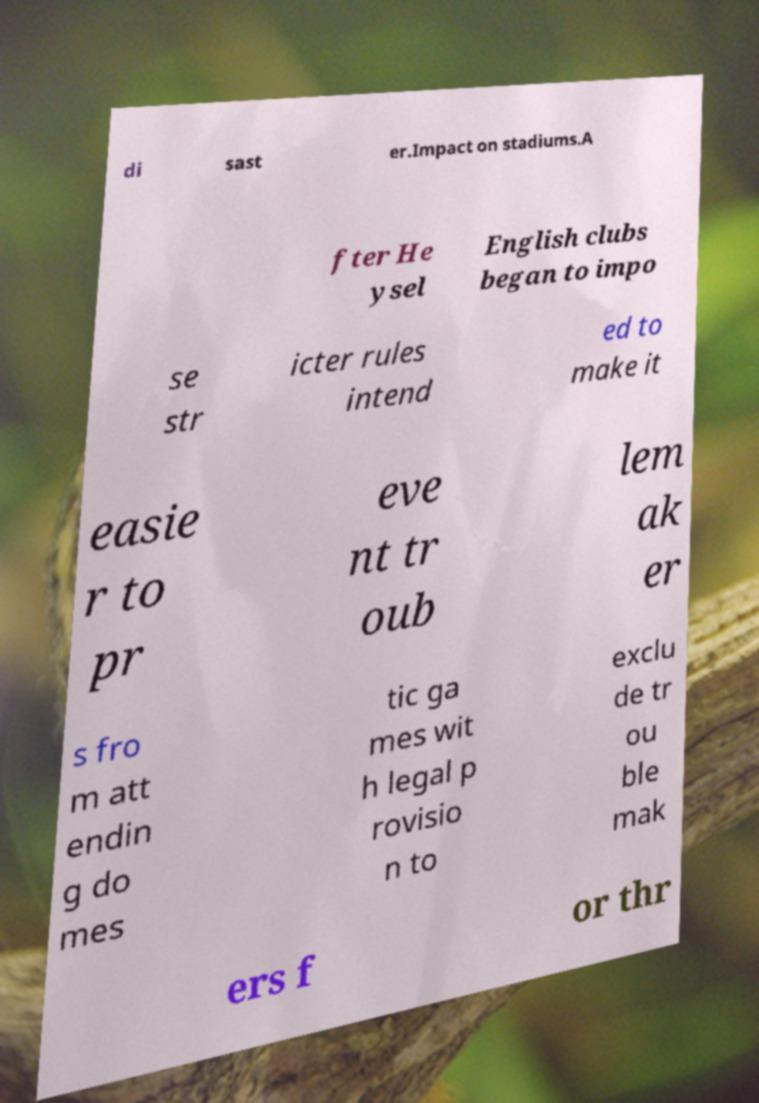Please identify and transcribe the text found in this image. di sast er.Impact on stadiums.A fter He ysel English clubs began to impo se str icter rules intend ed to make it easie r to pr eve nt tr oub lem ak er s fro m att endin g do mes tic ga mes wit h legal p rovisio n to exclu de tr ou ble mak ers f or thr 